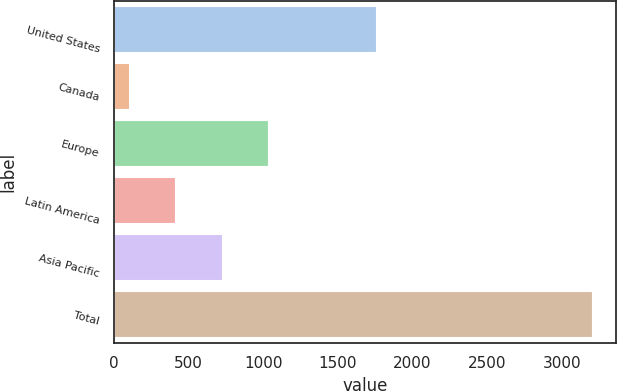Convert chart to OTSL. <chart><loc_0><loc_0><loc_500><loc_500><bar_chart><fcel>United States<fcel>Canada<fcel>Europe<fcel>Latin America<fcel>Asia Pacific<fcel>Total<nl><fcel>1758.8<fcel>100.8<fcel>1031.85<fcel>411.15<fcel>721.5<fcel>3204.3<nl></chart> 